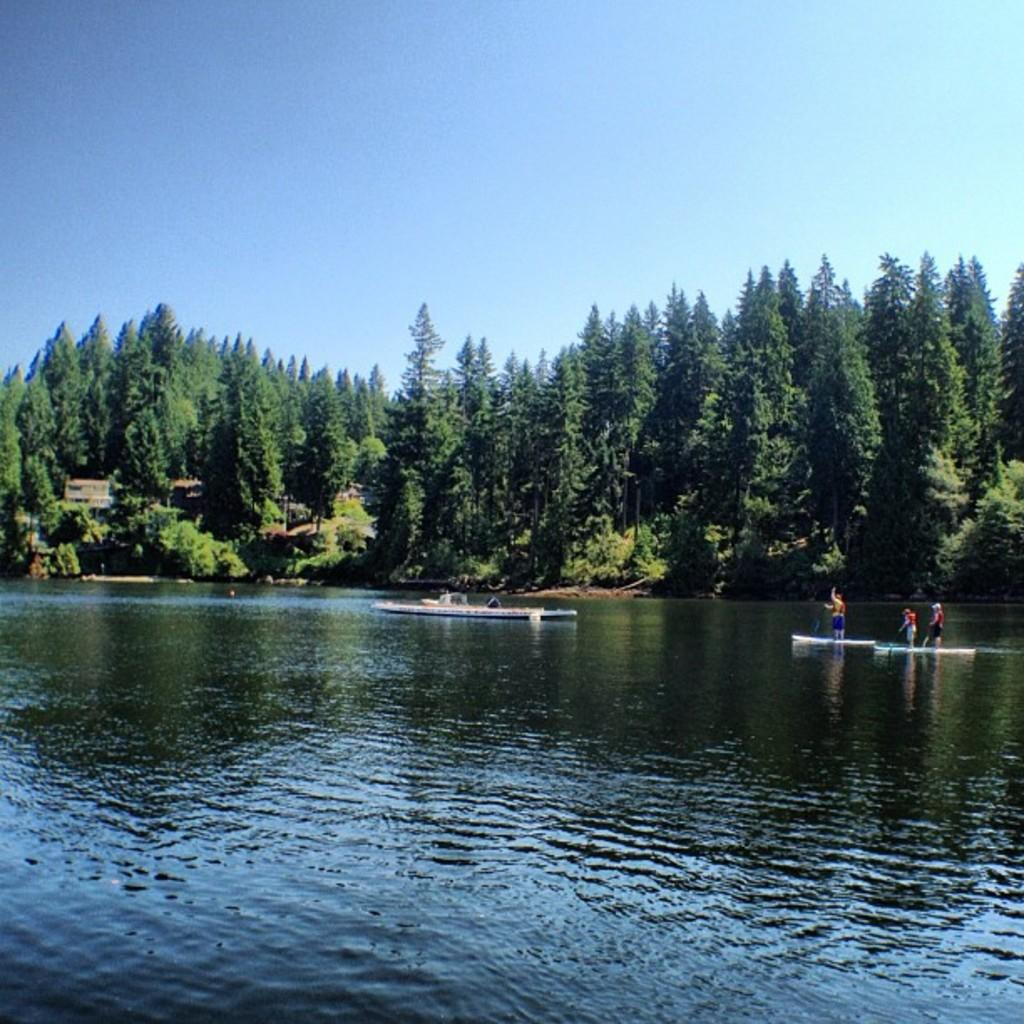Who or what can be seen in the image? There are people in the image. What are the people doing in the image? The provided facts do not specify what the people are doing, but we can see that they are near boats above the water. What can be seen in the background of the image? There are trees and the sky visible in the background of the image. What type of cactus can be seen in the image? There is no cactus present in the image. How does the feeling of the people in the image change throughout the day? The provided facts do not give any information about the feelings of the people in the image, nor do they suggest that the image represents a specific time of day. 